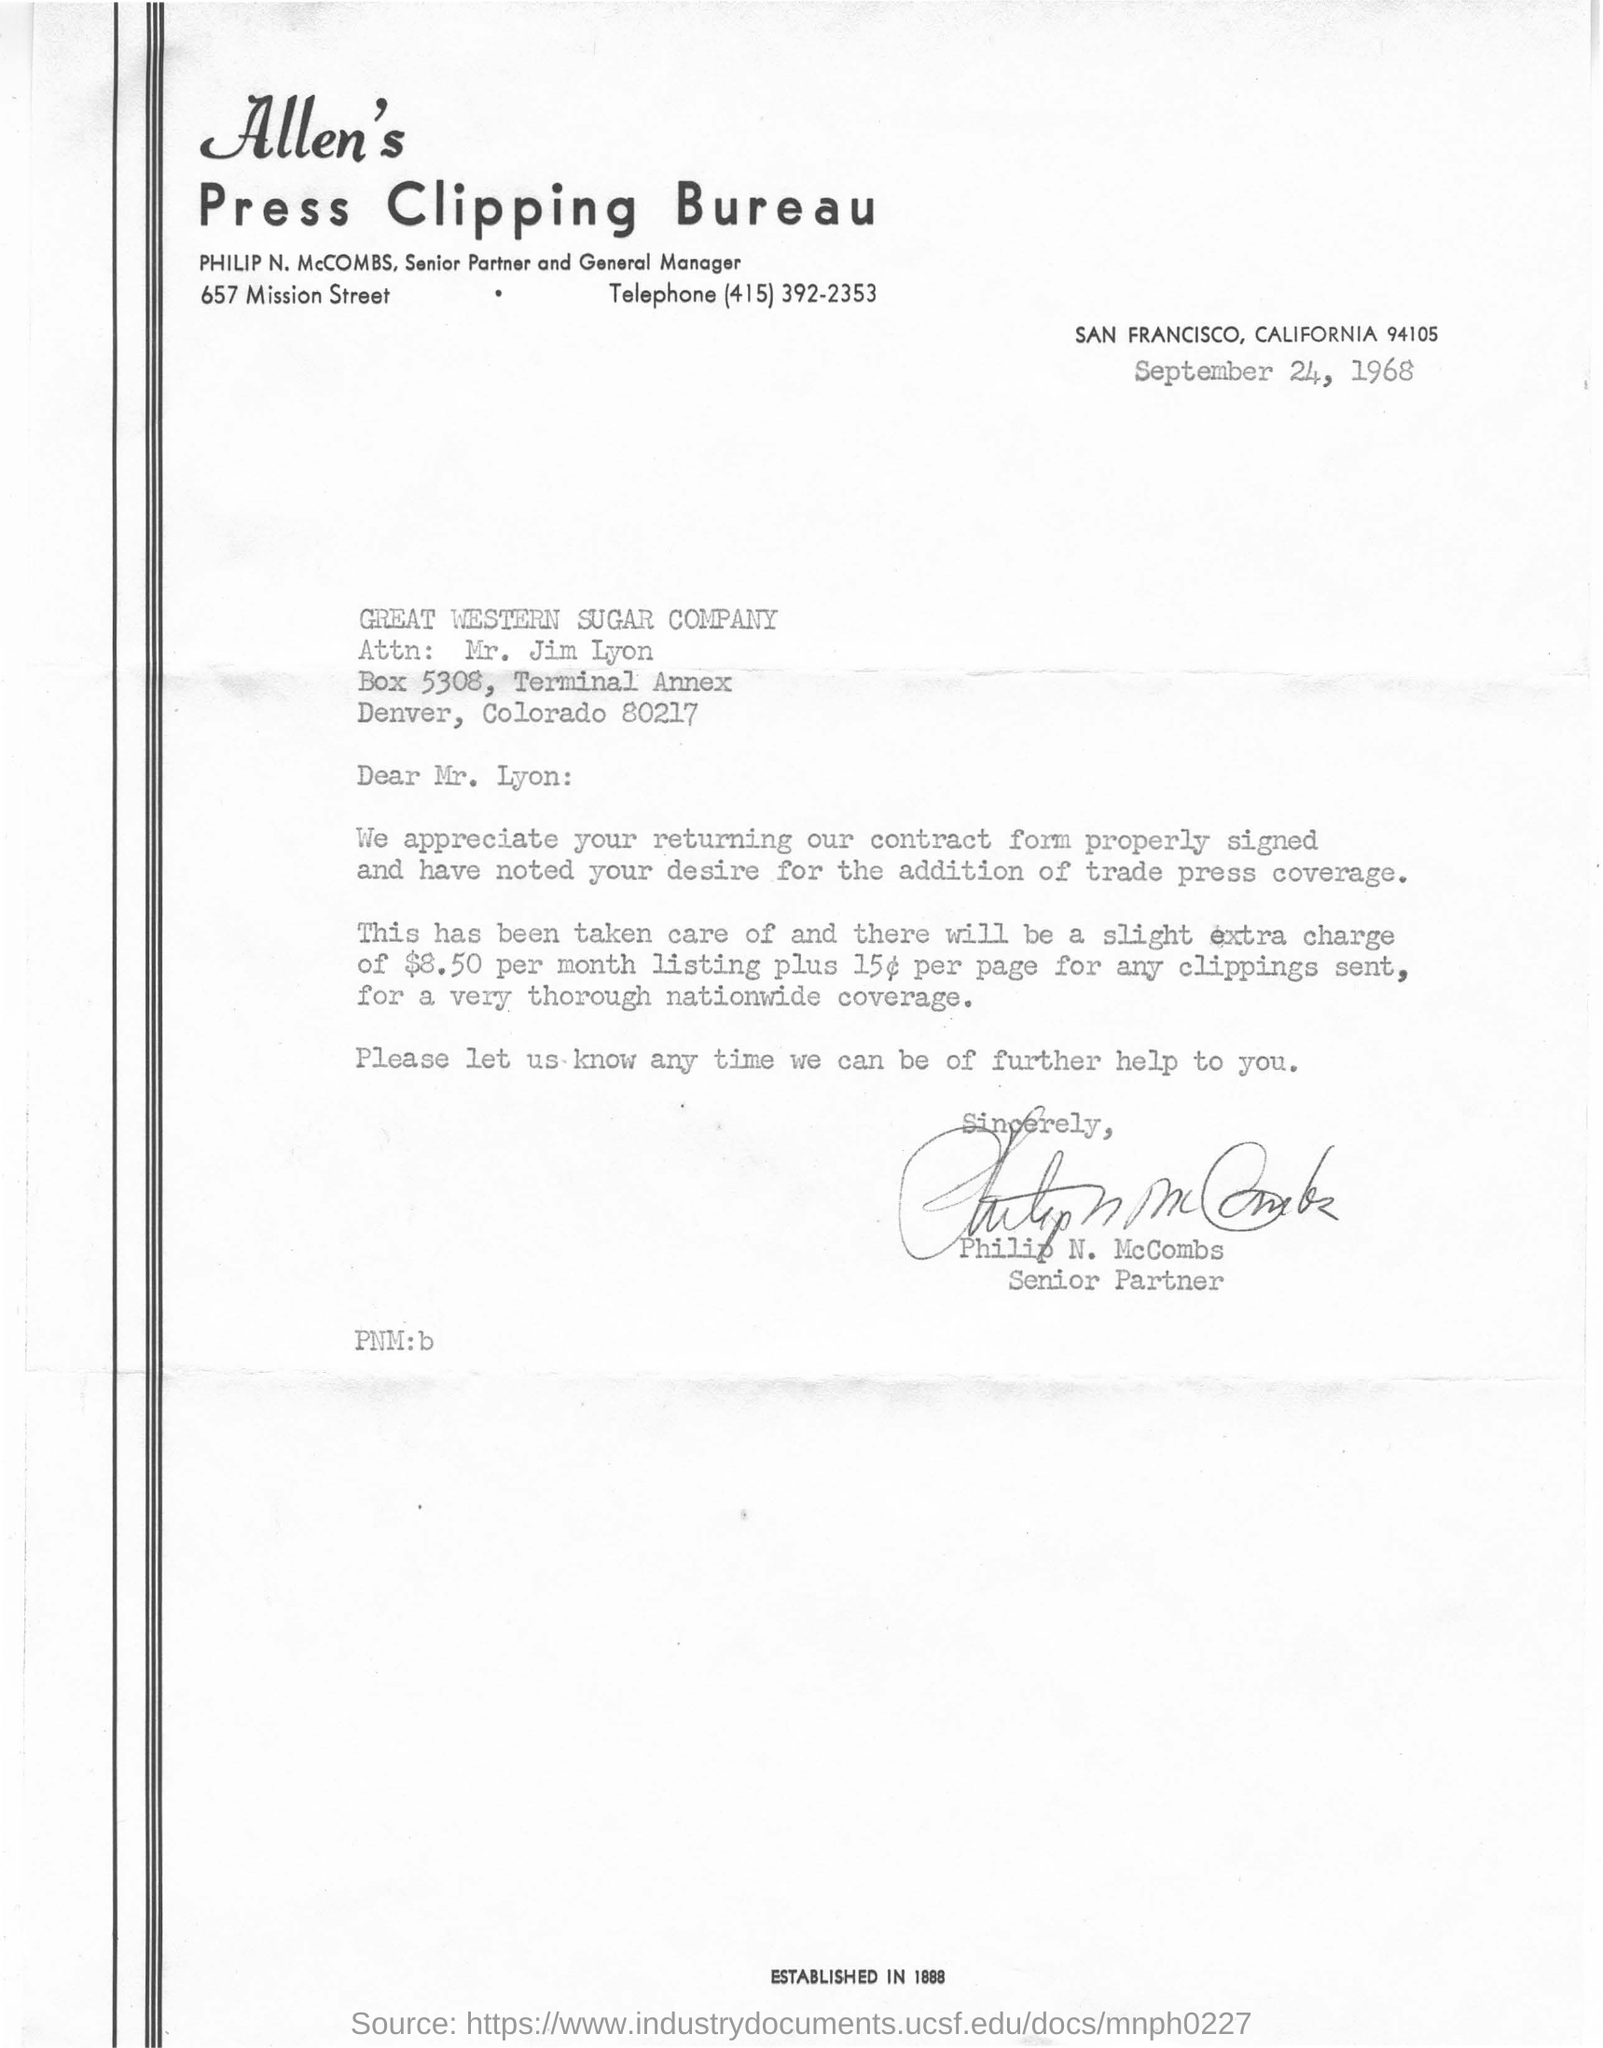What is the date mentioned in the document?
Offer a very short reply. SEPTEMBER 24, 1968. Who is a senior partner ?
Provide a short and direct response. PHILIP N. McCOMBS. 